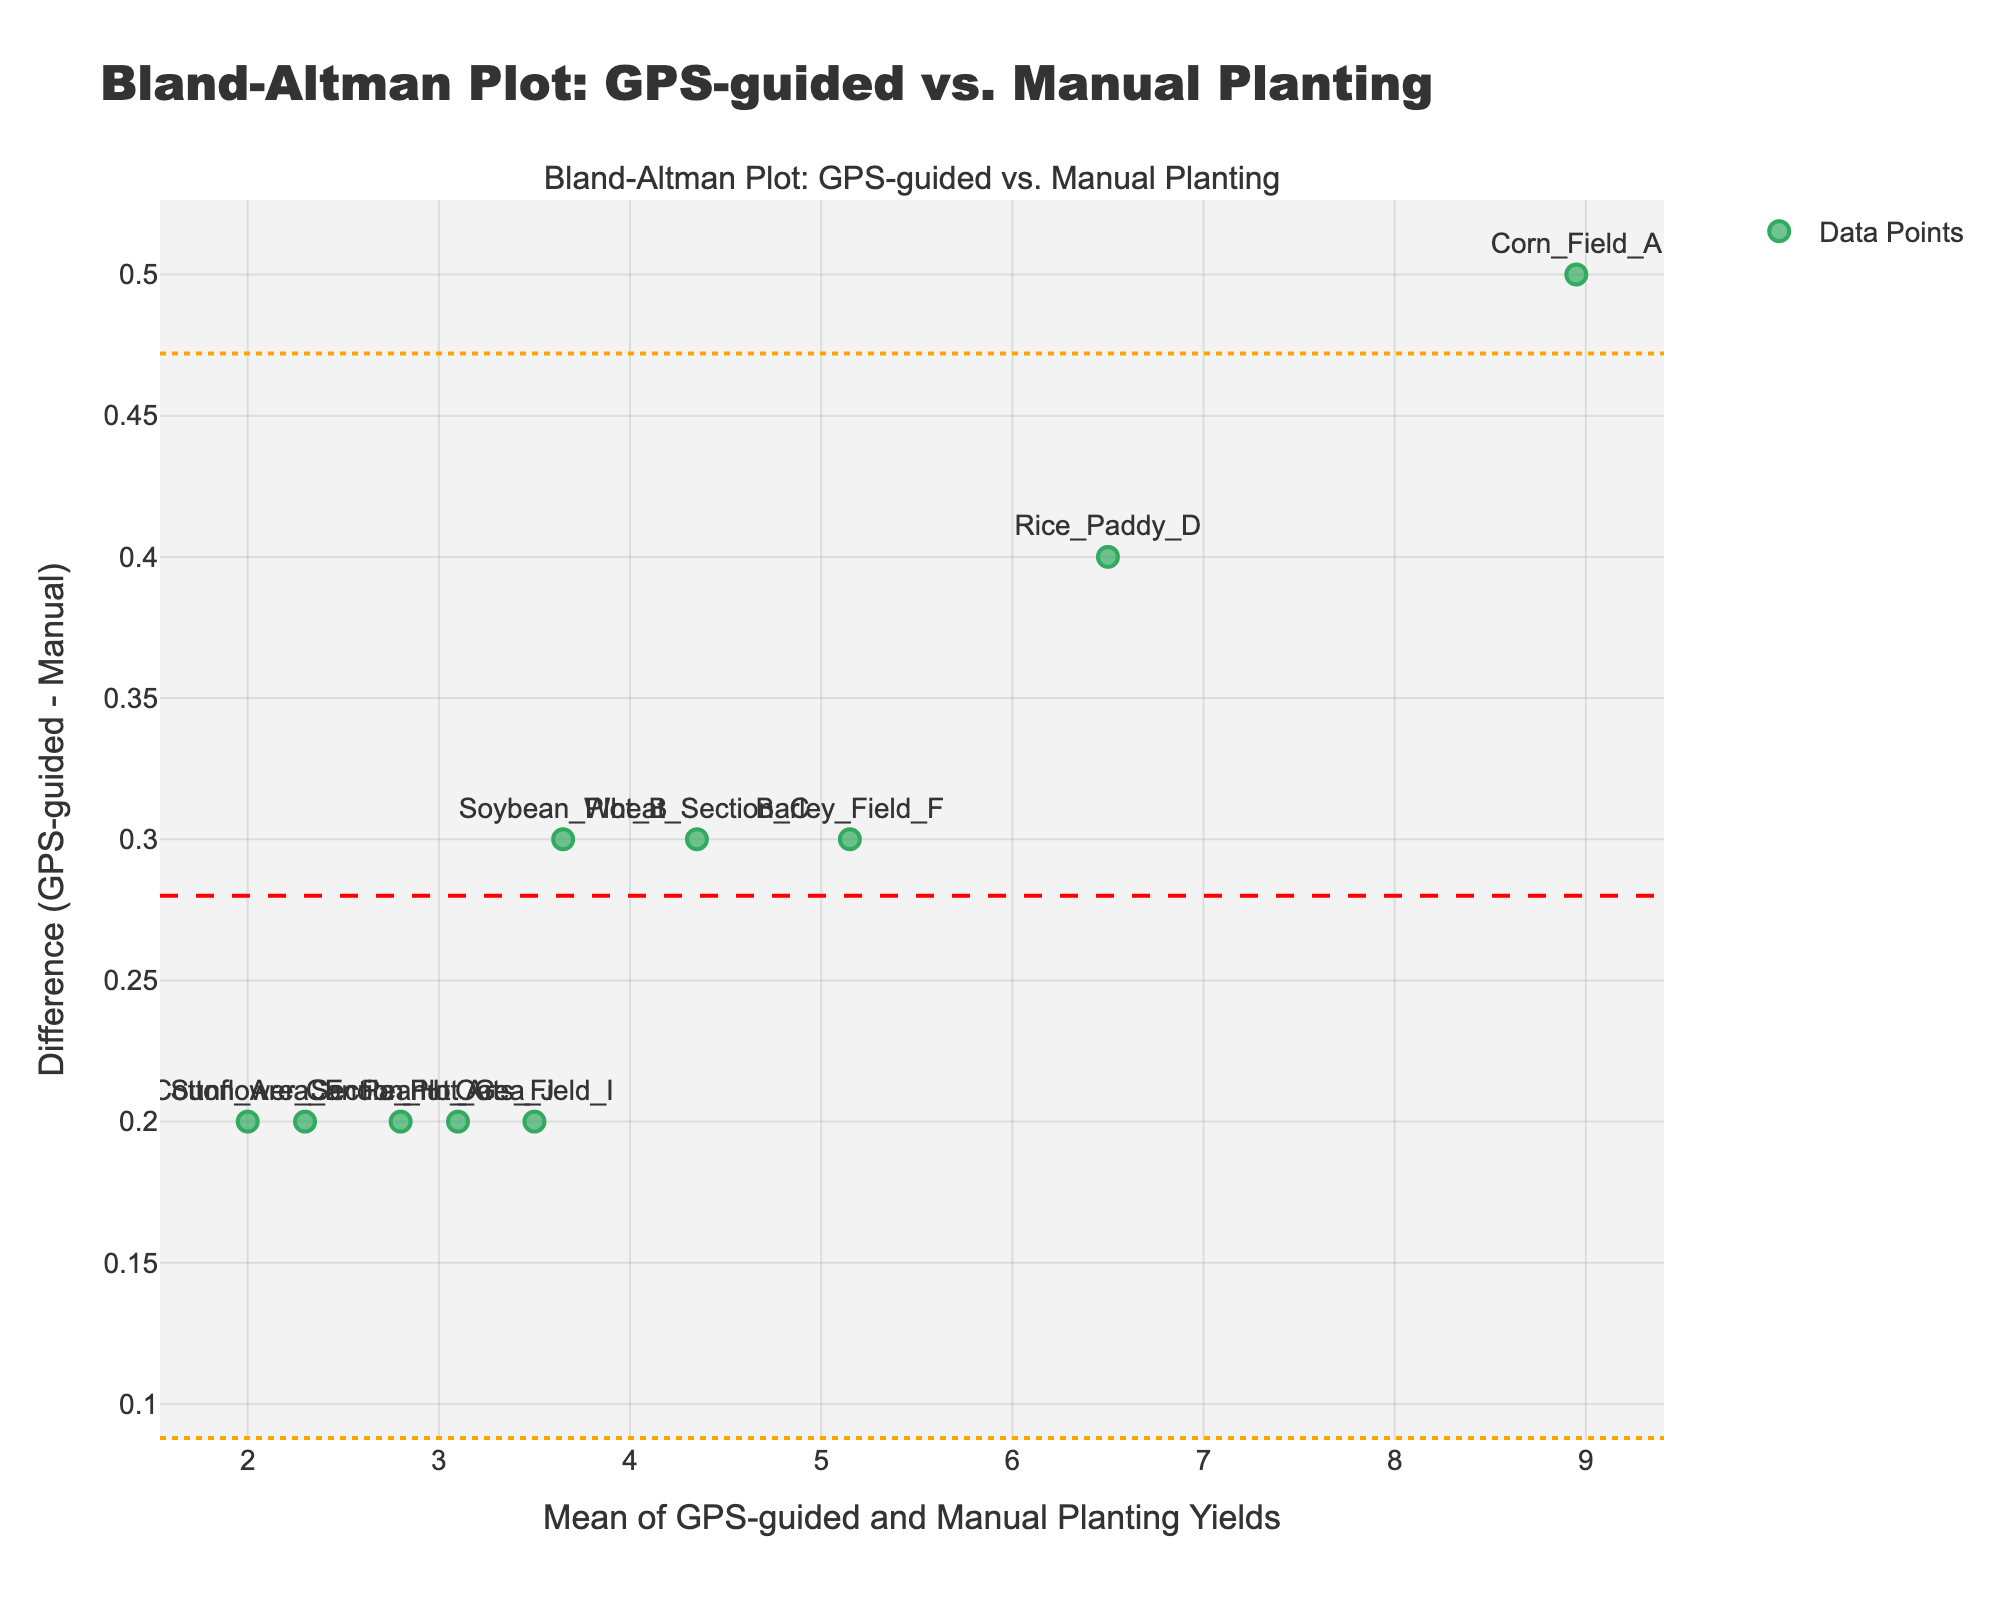How many data points are present in the plot? You can count the individual markers to determine the number of data points in the plot. There are markers labeled with farm types, from Corn_Field_A to Peanut_Area_J.
Answer: 10 What's the mean difference between GPS-guided yields and manual planting yields? The mean difference is represented by the dashed red line. It is visually indicated on the y-axis where this line intersects.
Answer: Approximately 0.35 What is the upper limit of agreement (LoA) for the plot? The upper limit of agreement (LoA) is represented by the upper dotted orange line. It is located at the y-axis value where this line intersects.
Answer: Approximately 0.557 What is the lower limit of agreement (LoA) for the plot? The lower limit of agreement (LoA) is represented by the lower dotted orange line. It is found at the y-axis value where this line intersects.
Answer: Approximately 0.143 Which farm type has the smallest difference between GPS-guided and manual planting yields? Look at the data points that are closest to the x-axis, which means the smallest difference.
Answer: Cotton_Area_E Which farm type shows the largest positive difference between GPS-guided and manual planting yields? Identify the data point highest above the x-axis, indicating the largest positive difference.
Answer: Corn_Field_A What is the average yield for "Soybean_Plot_B" across both methods? The average yield can be calculated by taking the mean of the GPS-guided and manual planting values for Soybean_Plot_B (3.8 and 3.5 respectively).
Answer: 3.65 Is the yield difference for "Barley_Field_F" within the limits of agreement? Barley_Field_F's difference point must be checked to see if it lies between the upper and lower limits of agreement (0.557 and 0.143).
Answer: Yes Which farm types have yields with differences outside the limits of agreement? Identify the data points that lie outside the orange dotted lines representing the limits of agreement.
Answer: None Do more data points lie above or below the mean difference line? Count the markers above and below the dashed red line representing the mean difference, and compare the counts.
Answer: Above 